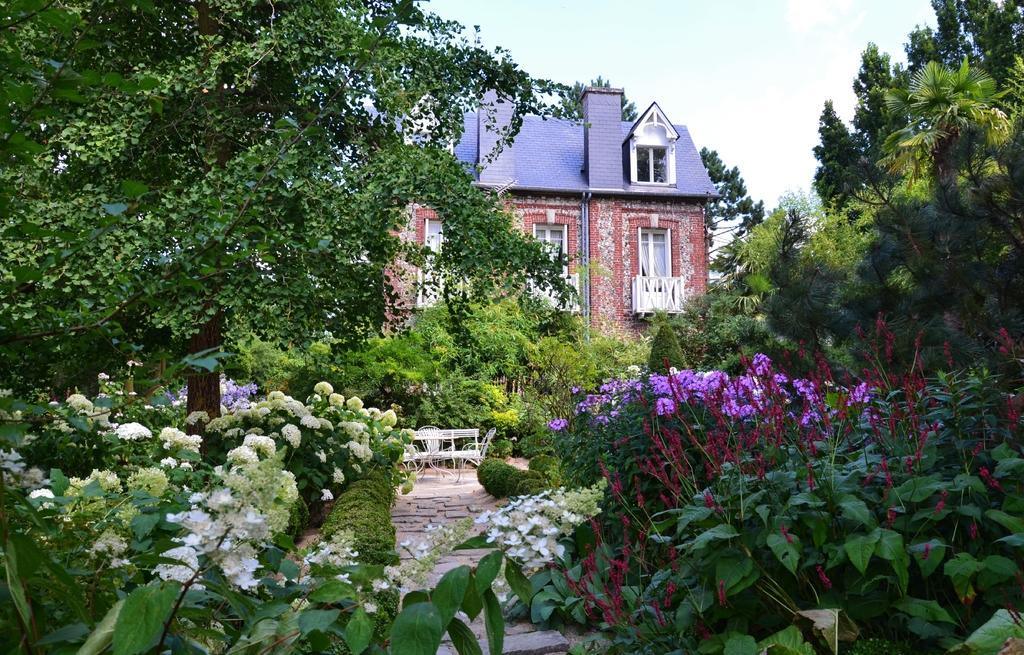Could you give a brief overview of what you see in this image? This picture shows few trees and a building and we see plants with flowers and we see a bench and couple of chairs and a cloudy sky. 